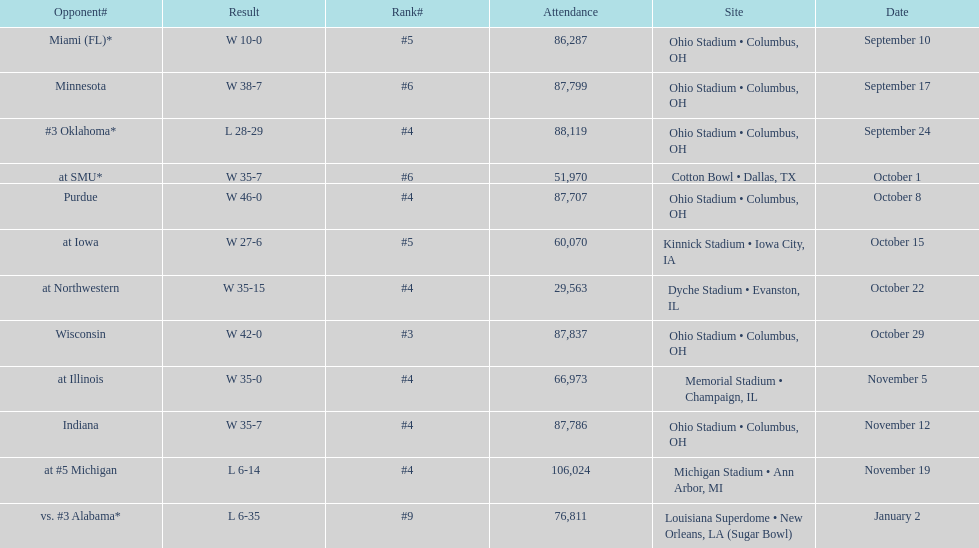Which date was attended by the most people? November 19. 